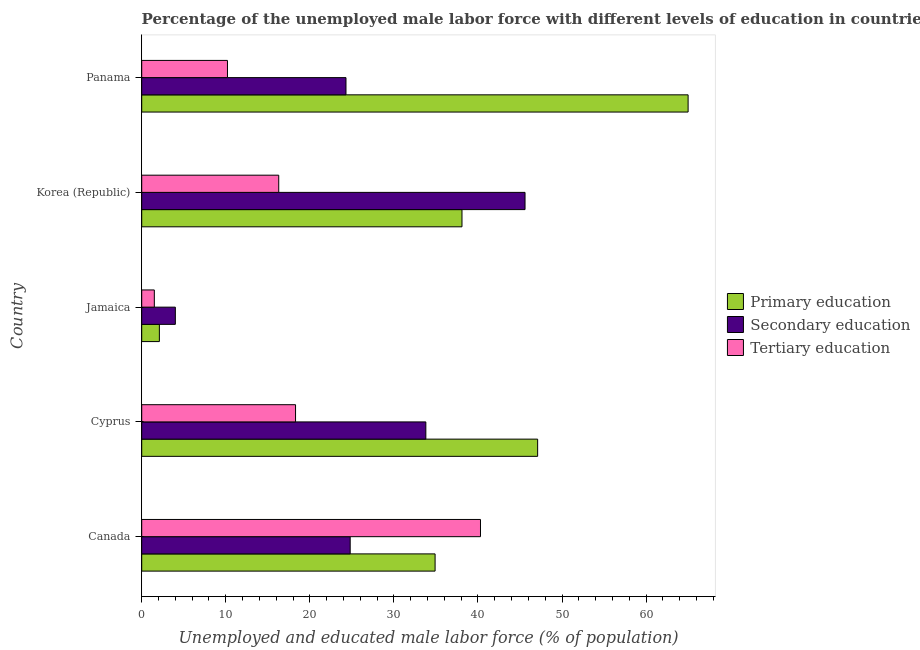How many groups of bars are there?
Your response must be concise. 5. Are the number of bars on each tick of the Y-axis equal?
Provide a succinct answer. Yes. How many bars are there on the 5th tick from the top?
Offer a very short reply. 3. What is the label of the 3rd group of bars from the top?
Your answer should be very brief. Jamaica. What is the percentage of male labor force who received primary education in Canada?
Ensure brevity in your answer.  34.9. Across all countries, what is the maximum percentage of male labor force who received secondary education?
Keep it short and to the point. 45.6. Across all countries, what is the minimum percentage of male labor force who received tertiary education?
Provide a succinct answer. 1.5. In which country was the percentage of male labor force who received secondary education minimum?
Your answer should be very brief. Jamaica. What is the total percentage of male labor force who received tertiary education in the graph?
Provide a succinct answer. 86.6. What is the difference between the percentage of male labor force who received primary education in Cyprus and that in Korea (Republic)?
Your answer should be compact. 9. What is the average percentage of male labor force who received primary education per country?
Keep it short and to the point. 37.44. In how many countries, is the percentage of male labor force who received tertiary education greater than 30 %?
Offer a very short reply. 1. What is the ratio of the percentage of male labor force who received primary education in Cyprus to that in Korea (Republic)?
Offer a very short reply. 1.24. Is the percentage of male labor force who received tertiary education in Jamaica less than that in Panama?
Your response must be concise. Yes. Is the difference between the percentage of male labor force who received primary education in Canada and Cyprus greater than the difference between the percentage of male labor force who received tertiary education in Canada and Cyprus?
Ensure brevity in your answer.  No. What is the difference between the highest and the second highest percentage of male labor force who received primary education?
Keep it short and to the point. 17.9. What is the difference between the highest and the lowest percentage of male labor force who received primary education?
Offer a very short reply. 62.9. In how many countries, is the percentage of male labor force who received secondary education greater than the average percentage of male labor force who received secondary education taken over all countries?
Keep it short and to the point. 2. Is the sum of the percentage of male labor force who received primary education in Canada and Panama greater than the maximum percentage of male labor force who received secondary education across all countries?
Offer a terse response. Yes. What does the 1st bar from the top in Panama represents?
Your answer should be compact. Tertiary education. What does the 2nd bar from the bottom in Korea (Republic) represents?
Your response must be concise. Secondary education. How many bars are there?
Keep it short and to the point. 15. Are all the bars in the graph horizontal?
Your answer should be compact. Yes. What is the difference between two consecutive major ticks on the X-axis?
Provide a succinct answer. 10. Are the values on the major ticks of X-axis written in scientific E-notation?
Keep it short and to the point. No. Does the graph contain any zero values?
Your answer should be compact. No. Does the graph contain grids?
Offer a very short reply. No. Where does the legend appear in the graph?
Provide a short and direct response. Center right. How many legend labels are there?
Provide a short and direct response. 3. How are the legend labels stacked?
Offer a terse response. Vertical. What is the title of the graph?
Offer a very short reply. Percentage of the unemployed male labor force with different levels of education in countries. What is the label or title of the X-axis?
Keep it short and to the point. Unemployed and educated male labor force (% of population). What is the Unemployed and educated male labor force (% of population) of Primary education in Canada?
Keep it short and to the point. 34.9. What is the Unemployed and educated male labor force (% of population) of Secondary education in Canada?
Give a very brief answer. 24.8. What is the Unemployed and educated male labor force (% of population) of Tertiary education in Canada?
Your response must be concise. 40.3. What is the Unemployed and educated male labor force (% of population) of Primary education in Cyprus?
Keep it short and to the point. 47.1. What is the Unemployed and educated male labor force (% of population) in Secondary education in Cyprus?
Make the answer very short. 33.8. What is the Unemployed and educated male labor force (% of population) of Tertiary education in Cyprus?
Your response must be concise. 18.3. What is the Unemployed and educated male labor force (% of population) in Primary education in Jamaica?
Your answer should be compact. 2.1. What is the Unemployed and educated male labor force (% of population) of Tertiary education in Jamaica?
Provide a short and direct response. 1.5. What is the Unemployed and educated male labor force (% of population) of Primary education in Korea (Republic)?
Your response must be concise. 38.1. What is the Unemployed and educated male labor force (% of population) of Secondary education in Korea (Republic)?
Your answer should be compact. 45.6. What is the Unemployed and educated male labor force (% of population) of Tertiary education in Korea (Republic)?
Your response must be concise. 16.3. What is the Unemployed and educated male labor force (% of population) in Secondary education in Panama?
Your answer should be compact. 24.3. What is the Unemployed and educated male labor force (% of population) of Tertiary education in Panama?
Make the answer very short. 10.2. Across all countries, what is the maximum Unemployed and educated male labor force (% of population) in Primary education?
Your answer should be compact. 65. Across all countries, what is the maximum Unemployed and educated male labor force (% of population) of Secondary education?
Your response must be concise. 45.6. Across all countries, what is the maximum Unemployed and educated male labor force (% of population) in Tertiary education?
Offer a terse response. 40.3. Across all countries, what is the minimum Unemployed and educated male labor force (% of population) in Primary education?
Offer a terse response. 2.1. What is the total Unemployed and educated male labor force (% of population) of Primary education in the graph?
Give a very brief answer. 187.2. What is the total Unemployed and educated male labor force (% of population) in Secondary education in the graph?
Make the answer very short. 132.5. What is the total Unemployed and educated male labor force (% of population) of Tertiary education in the graph?
Provide a short and direct response. 86.6. What is the difference between the Unemployed and educated male labor force (% of population) in Primary education in Canada and that in Jamaica?
Keep it short and to the point. 32.8. What is the difference between the Unemployed and educated male labor force (% of population) in Secondary education in Canada and that in Jamaica?
Ensure brevity in your answer.  20.8. What is the difference between the Unemployed and educated male labor force (% of population) of Tertiary education in Canada and that in Jamaica?
Provide a succinct answer. 38.8. What is the difference between the Unemployed and educated male labor force (% of population) in Secondary education in Canada and that in Korea (Republic)?
Offer a terse response. -20.8. What is the difference between the Unemployed and educated male labor force (% of population) of Tertiary education in Canada and that in Korea (Republic)?
Your answer should be compact. 24. What is the difference between the Unemployed and educated male labor force (% of population) of Primary education in Canada and that in Panama?
Your response must be concise. -30.1. What is the difference between the Unemployed and educated male labor force (% of population) of Tertiary education in Canada and that in Panama?
Offer a terse response. 30.1. What is the difference between the Unemployed and educated male labor force (% of population) of Primary education in Cyprus and that in Jamaica?
Your answer should be very brief. 45. What is the difference between the Unemployed and educated male labor force (% of population) in Secondary education in Cyprus and that in Jamaica?
Your answer should be compact. 29.8. What is the difference between the Unemployed and educated male labor force (% of population) in Primary education in Cyprus and that in Korea (Republic)?
Keep it short and to the point. 9. What is the difference between the Unemployed and educated male labor force (% of population) of Secondary education in Cyprus and that in Korea (Republic)?
Provide a short and direct response. -11.8. What is the difference between the Unemployed and educated male labor force (% of population) of Primary education in Cyprus and that in Panama?
Make the answer very short. -17.9. What is the difference between the Unemployed and educated male labor force (% of population) in Primary education in Jamaica and that in Korea (Republic)?
Make the answer very short. -36. What is the difference between the Unemployed and educated male labor force (% of population) of Secondary education in Jamaica and that in Korea (Republic)?
Your answer should be compact. -41.6. What is the difference between the Unemployed and educated male labor force (% of population) in Tertiary education in Jamaica and that in Korea (Republic)?
Your response must be concise. -14.8. What is the difference between the Unemployed and educated male labor force (% of population) of Primary education in Jamaica and that in Panama?
Ensure brevity in your answer.  -62.9. What is the difference between the Unemployed and educated male labor force (% of population) of Secondary education in Jamaica and that in Panama?
Keep it short and to the point. -20.3. What is the difference between the Unemployed and educated male labor force (% of population) in Tertiary education in Jamaica and that in Panama?
Provide a short and direct response. -8.7. What is the difference between the Unemployed and educated male labor force (% of population) of Primary education in Korea (Republic) and that in Panama?
Your answer should be compact. -26.9. What is the difference between the Unemployed and educated male labor force (% of population) in Secondary education in Korea (Republic) and that in Panama?
Your answer should be compact. 21.3. What is the difference between the Unemployed and educated male labor force (% of population) of Tertiary education in Korea (Republic) and that in Panama?
Your response must be concise. 6.1. What is the difference between the Unemployed and educated male labor force (% of population) of Primary education in Canada and the Unemployed and educated male labor force (% of population) of Secondary education in Cyprus?
Provide a succinct answer. 1.1. What is the difference between the Unemployed and educated male labor force (% of population) in Secondary education in Canada and the Unemployed and educated male labor force (% of population) in Tertiary education in Cyprus?
Keep it short and to the point. 6.5. What is the difference between the Unemployed and educated male labor force (% of population) in Primary education in Canada and the Unemployed and educated male labor force (% of population) in Secondary education in Jamaica?
Ensure brevity in your answer.  30.9. What is the difference between the Unemployed and educated male labor force (% of population) of Primary education in Canada and the Unemployed and educated male labor force (% of population) of Tertiary education in Jamaica?
Give a very brief answer. 33.4. What is the difference between the Unemployed and educated male labor force (% of population) in Secondary education in Canada and the Unemployed and educated male labor force (% of population) in Tertiary education in Jamaica?
Offer a terse response. 23.3. What is the difference between the Unemployed and educated male labor force (% of population) of Primary education in Canada and the Unemployed and educated male labor force (% of population) of Secondary education in Korea (Republic)?
Make the answer very short. -10.7. What is the difference between the Unemployed and educated male labor force (% of population) in Primary education in Canada and the Unemployed and educated male labor force (% of population) in Secondary education in Panama?
Ensure brevity in your answer.  10.6. What is the difference between the Unemployed and educated male labor force (% of population) in Primary education in Canada and the Unemployed and educated male labor force (% of population) in Tertiary education in Panama?
Keep it short and to the point. 24.7. What is the difference between the Unemployed and educated male labor force (% of population) of Primary education in Cyprus and the Unemployed and educated male labor force (% of population) of Secondary education in Jamaica?
Offer a terse response. 43.1. What is the difference between the Unemployed and educated male labor force (% of population) of Primary education in Cyprus and the Unemployed and educated male labor force (% of population) of Tertiary education in Jamaica?
Give a very brief answer. 45.6. What is the difference between the Unemployed and educated male labor force (% of population) in Secondary education in Cyprus and the Unemployed and educated male labor force (% of population) in Tertiary education in Jamaica?
Keep it short and to the point. 32.3. What is the difference between the Unemployed and educated male labor force (% of population) in Primary education in Cyprus and the Unemployed and educated male labor force (% of population) in Tertiary education in Korea (Republic)?
Provide a succinct answer. 30.8. What is the difference between the Unemployed and educated male labor force (% of population) in Primary education in Cyprus and the Unemployed and educated male labor force (% of population) in Secondary education in Panama?
Offer a terse response. 22.8. What is the difference between the Unemployed and educated male labor force (% of population) of Primary education in Cyprus and the Unemployed and educated male labor force (% of population) of Tertiary education in Panama?
Your response must be concise. 36.9. What is the difference between the Unemployed and educated male labor force (% of population) of Secondary education in Cyprus and the Unemployed and educated male labor force (% of population) of Tertiary education in Panama?
Offer a terse response. 23.6. What is the difference between the Unemployed and educated male labor force (% of population) of Primary education in Jamaica and the Unemployed and educated male labor force (% of population) of Secondary education in Korea (Republic)?
Offer a terse response. -43.5. What is the difference between the Unemployed and educated male labor force (% of population) in Primary education in Jamaica and the Unemployed and educated male labor force (% of population) in Tertiary education in Korea (Republic)?
Your answer should be compact. -14.2. What is the difference between the Unemployed and educated male labor force (% of population) in Secondary education in Jamaica and the Unemployed and educated male labor force (% of population) in Tertiary education in Korea (Republic)?
Offer a very short reply. -12.3. What is the difference between the Unemployed and educated male labor force (% of population) of Primary education in Jamaica and the Unemployed and educated male labor force (% of population) of Secondary education in Panama?
Give a very brief answer. -22.2. What is the difference between the Unemployed and educated male labor force (% of population) of Secondary education in Jamaica and the Unemployed and educated male labor force (% of population) of Tertiary education in Panama?
Offer a very short reply. -6.2. What is the difference between the Unemployed and educated male labor force (% of population) of Primary education in Korea (Republic) and the Unemployed and educated male labor force (% of population) of Secondary education in Panama?
Make the answer very short. 13.8. What is the difference between the Unemployed and educated male labor force (% of population) in Primary education in Korea (Republic) and the Unemployed and educated male labor force (% of population) in Tertiary education in Panama?
Provide a succinct answer. 27.9. What is the difference between the Unemployed and educated male labor force (% of population) of Secondary education in Korea (Republic) and the Unemployed and educated male labor force (% of population) of Tertiary education in Panama?
Keep it short and to the point. 35.4. What is the average Unemployed and educated male labor force (% of population) of Primary education per country?
Provide a succinct answer. 37.44. What is the average Unemployed and educated male labor force (% of population) in Secondary education per country?
Your answer should be very brief. 26.5. What is the average Unemployed and educated male labor force (% of population) of Tertiary education per country?
Your answer should be very brief. 17.32. What is the difference between the Unemployed and educated male labor force (% of population) in Primary education and Unemployed and educated male labor force (% of population) in Secondary education in Canada?
Offer a terse response. 10.1. What is the difference between the Unemployed and educated male labor force (% of population) of Secondary education and Unemployed and educated male labor force (% of population) of Tertiary education in Canada?
Give a very brief answer. -15.5. What is the difference between the Unemployed and educated male labor force (% of population) in Primary education and Unemployed and educated male labor force (% of population) in Tertiary education in Cyprus?
Your answer should be very brief. 28.8. What is the difference between the Unemployed and educated male labor force (% of population) in Primary education and Unemployed and educated male labor force (% of population) in Secondary education in Jamaica?
Offer a very short reply. -1.9. What is the difference between the Unemployed and educated male labor force (% of population) of Primary education and Unemployed and educated male labor force (% of population) of Tertiary education in Jamaica?
Give a very brief answer. 0.6. What is the difference between the Unemployed and educated male labor force (% of population) of Primary education and Unemployed and educated male labor force (% of population) of Secondary education in Korea (Republic)?
Your answer should be compact. -7.5. What is the difference between the Unemployed and educated male labor force (% of population) of Primary education and Unemployed and educated male labor force (% of population) of Tertiary education in Korea (Republic)?
Your answer should be very brief. 21.8. What is the difference between the Unemployed and educated male labor force (% of population) of Secondary education and Unemployed and educated male labor force (% of population) of Tertiary education in Korea (Republic)?
Offer a terse response. 29.3. What is the difference between the Unemployed and educated male labor force (% of population) in Primary education and Unemployed and educated male labor force (% of population) in Secondary education in Panama?
Your answer should be compact. 40.7. What is the difference between the Unemployed and educated male labor force (% of population) in Primary education and Unemployed and educated male labor force (% of population) in Tertiary education in Panama?
Offer a terse response. 54.8. What is the ratio of the Unemployed and educated male labor force (% of population) in Primary education in Canada to that in Cyprus?
Provide a short and direct response. 0.74. What is the ratio of the Unemployed and educated male labor force (% of population) of Secondary education in Canada to that in Cyprus?
Offer a terse response. 0.73. What is the ratio of the Unemployed and educated male labor force (% of population) in Tertiary education in Canada to that in Cyprus?
Give a very brief answer. 2.2. What is the ratio of the Unemployed and educated male labor force (% of population) of Primary education in Canada to that in Jamaica?
Provide a succinct answer. 16.62. What is the ratio of the Unemployed and educated male labor force (% of population) in Tertiary education in Canada to that in Jamaica?
Your response must be concise. 26.87. What is the ratio of the Unemployed and educated male labor force (% of population) in Primary education in Canada to that in Korea (Republic)?
Provide a short and direct response. 0.92. What is the ratio of the Unemployed and educated male labor force (% of population) of Secondary education in Canada to that in Korea (Republic)?
Ensure brevity in your answer.  0.54. What is the ratio of the Unemployed and educated male labor force (% of population) in Tertiary education in Canada to that in Korea (Republic)?
Your answer should be compact. 2.47. What is the ratio of the Unemployed and educated male labor force (% of population) of Primary education in Canada to that in Panama?
Give a very brief answer. 0.54. What is the ratio of the Unemployed and educated male labor force (% of population) in Secondary education in Canada to that in Panama?
Provide a short and direct response. 1.02. What is the ratio of the Unemployed and educated male labor force (% of population) in Tertiary education in Canada to that in Panama?
Provide a short and direct response. 3.95. What is the ratio of the Unemployed and educated male labor force (% of population) of Primary education in Cyprus to that in Jamaica?
Provide a succinct answer. 22.43. What is the ratio of the Unemployed and educated male labor force (% of population) in Secondary education in Cyprus to that in Jamaica?
Offer a very short reply. 8.45. What is the ratio of the Unemployed and educated male labor force (% of population) in Primary education in Cyprus to that in Korea (Republic)?
Provide a succinct answer. 1.24. What is the ratio of the Unemployed and educated male labor force (% of population) in Secondary education in Cyprus to that in Korea (Republic)?
Provide a succinct answer. 0.74. What is the ratio of the Unemployed and educated male labor force (% of population) in Tertiary education in Cyprus to that in Korea (Republic)?
Give a very brief answer. 1.12. What is the ratio of the Unemployed and educated male labor force (% of population) in Primary education in Cyprus to that in Panama?
Your answer should be compact. 0.72. What is the ratio of the Unemployed and educated male labor force (% of population) in Secondary education in Cyprus to that in Panama?
Your answer should be compact. 1.39. What is the ratio of the Unemployed and educated male labor force (% of population) of Tertiary education in Cyprus to that in Panama?
Keep it short and to the point. 1.79. What is the ratio of the Unemployed and educated male labor force (% of population) in Primary education in Jamaica to that in Korea (Republic)?
Provide a short and direct response. 0.06. What is the ratio of the Unemployed and educated male labor force (% of population) of Secondary education in Jamaica to that in Korea (Republic)?
Keep it short and to the point. 0.09. What is the ratio of the Unemployed and educated male labor force (% of population) of Tertiary education in Jamaica to that in Korea (Republic)?
Keep it short and to the point. 0.09. What is the ratio of the Unemployed and educated male labor force (% of population) of Primary education in Jamaica to that in Panama?
Your response must be concise. 0.03. What is the ratio of the Unemployed and educated male labor force (% of population) in Secondary education in Jamaica to that in Panama?
Provide a short and direct response. 0.16. What is the ratio of the Unemployed and educated male labor force (% of population) in Tertiary education in Jamaica to that in Panama?
Ensure brevity in your answer.  0.15. What is the ratio of the Unemployed and educated male labor force (% of population) of Primary education in Korea (Republic) to that in Panama?
Keep it short and to the point. 0.59. What is the ratio of the Unemployed and educated male labor force (% of population) of Secondary education in Korea (Republic) to that in Panama?
Ensure brevity in your answer.  1.88. What is the ratio of the Unemployed and educated male labor force (% of population) in Tertiary education in Korea (Republic) to that in Panama?
Your answer should be compact. 1.6. What is the difference between the highest and the second highest Unemployed and educated male labor force (% of population) of Secondary education?
Give a very brief answer. 11.8. What is the difference between the highest and the lowest Unemployed and educated male labor force (% of population) of Primary education?
Provide a short and direct response. 62.9. What is the difference between the highest and the lowest Unemployed and educated male labor force (% of population) of Secondary education?
Your answer should be very brief. 41.6. What is the difference between the highest and the lowest Unemployed and educated male labor force (% of population) of Tertiary education?
Provide a succinct answer. 38.8. 